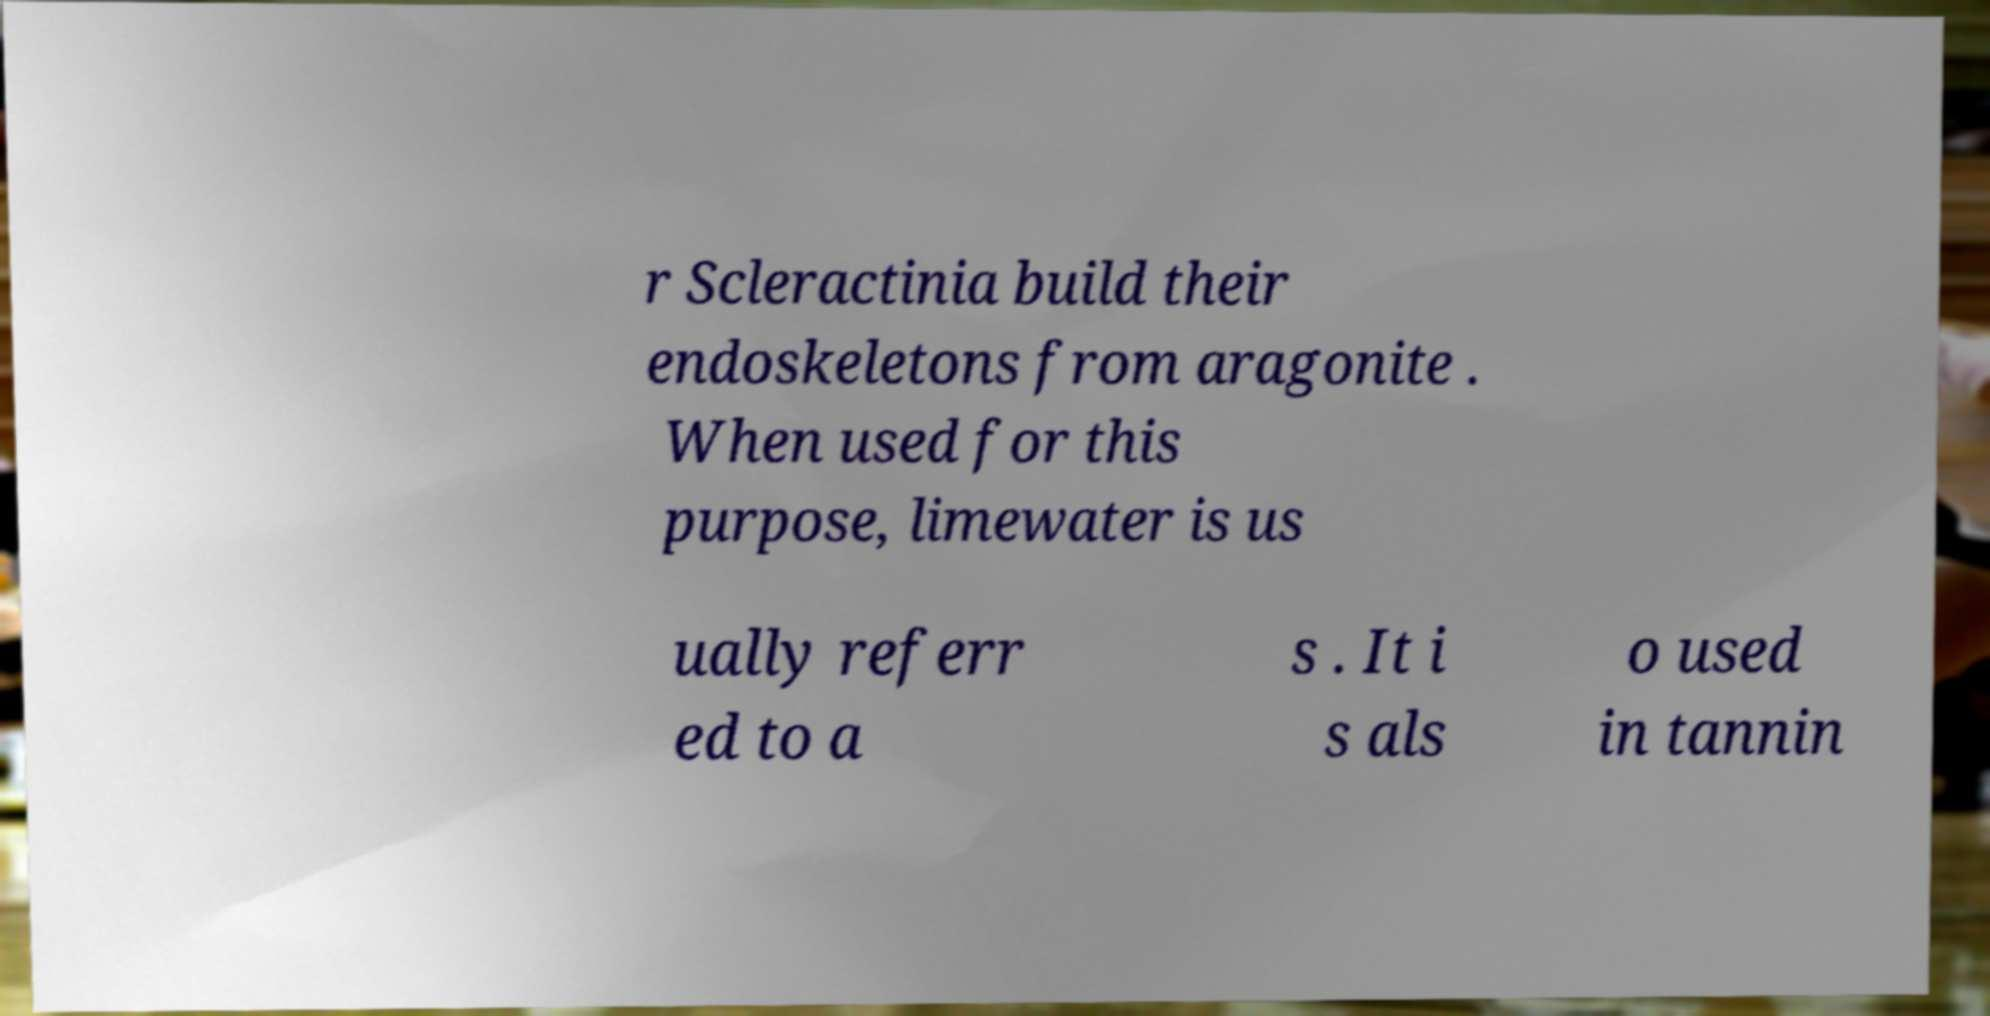Please identify and transcribe the text found in this image. r Scleractinia build their endoskeletons from aragonite . When used for this purpose, limewater is us ually referr ed to a s . It i s als o used in tannin 